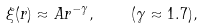Convert formula to latex. <formula><loc_0><loc_0><loc_500><loc_500>\xi ( r ) \approx A r ^ { - \gamma } , \quad ( \gamma \approx 1 . 7 ) ,</formula> 